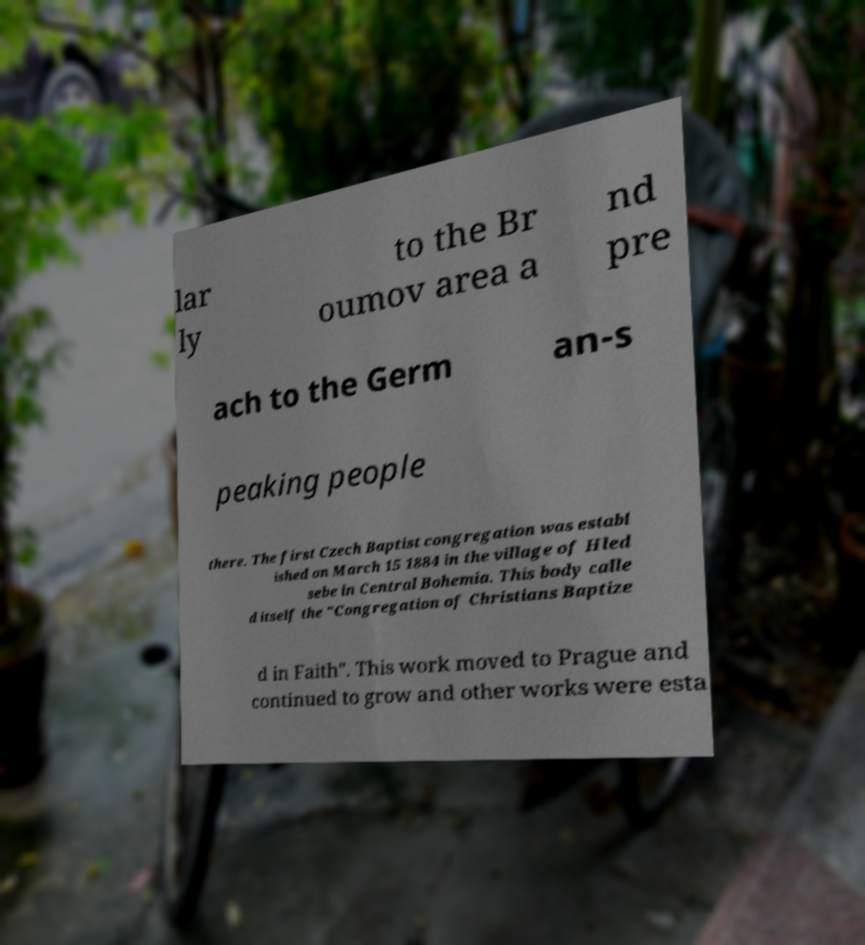Please read and relay the text visible in this image. What does it say? lar ly to the Br oumov area a nd pre ach to the Germ an-s peaking people there. The first Czech Baptist congregation was establ ished on March 15 1884 in the village of Hled sebe in Central Bohemia. This body calle d itself the "Congregation of Christians Baptize d in Faith". This work moved to Prague and continued to grow and other works were esta 